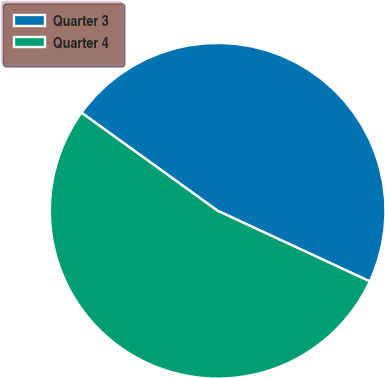Convert chart. <chart><loc_0><loc_0><loc_500><loc_500><pie_chart><fcel>Quarter 3<fcel>Quarter 4<nl><fcel>46.98%<fcel>53.02%<nl></chart> 